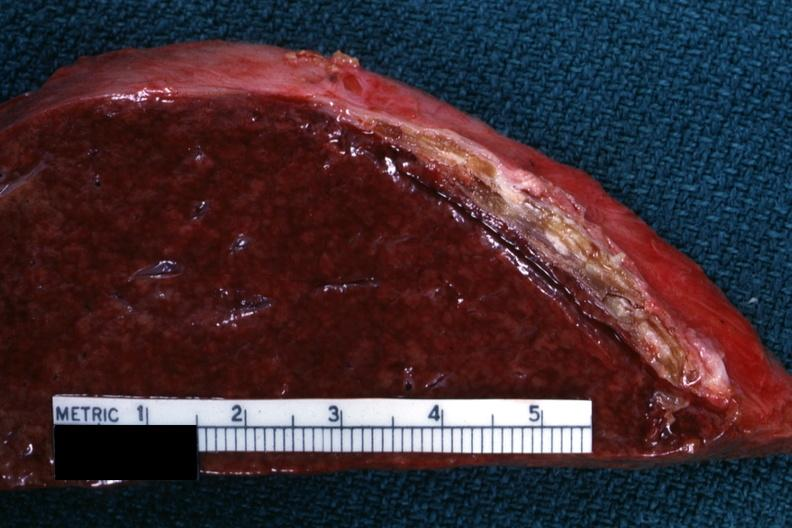s vasculature present?
Answer the question using a single word or phrase. No 